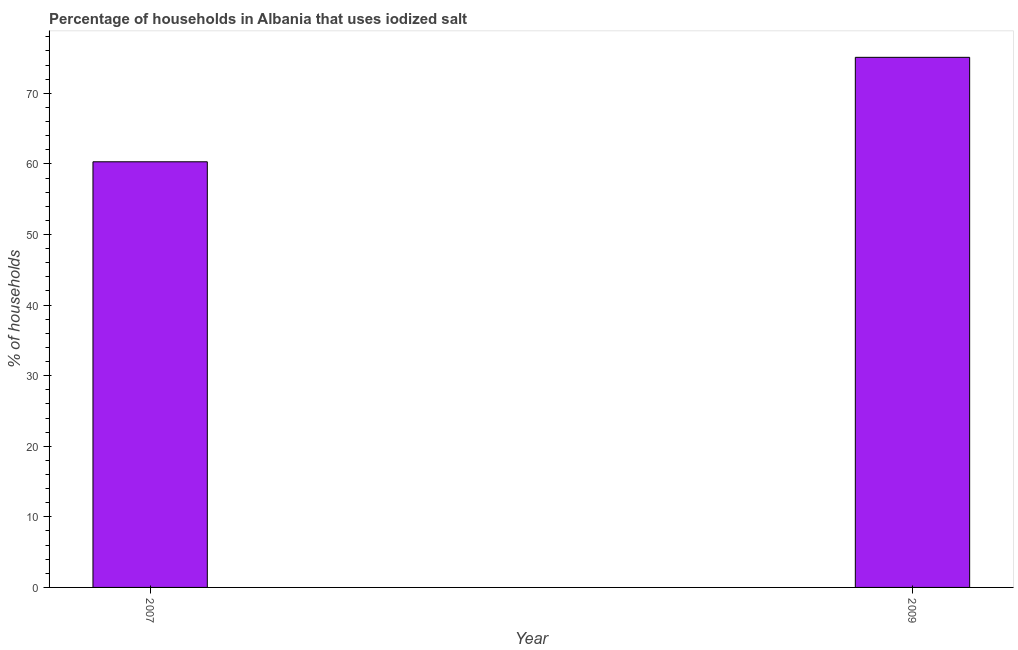Does the graph contain any zero values?
Your answer should be compact. No. Does the graph contain grids?
Your answer should be compact. No. What is the title of the graph?
Your response must be concise. Percentage of households in Albania that uses iodized salt. What is the label or title of the X-axis?
Your answer should be compact. Year. What is the label or title of the Y-axis?
Make the answer very short. % of households. What is the percentage of households where iodized salt is consumed in 2007?
Offer a terse response. 60.3. Across all years, what is the maximum percentage of households where iodized salt is consumed?
Your response must be concise. 75.1. Across all years, what is the minimum percentage of households where iodized salt is consumed?
Your response must be concise. 60.3. In which year was the percentage of households where iodized salt is consumed minimum?
Your answer should be very brief. 2007. What is the sum of the percentage of households where iodized salt is consumed?
Offer a terse response. 135.4. What is the difference between the percentage of households where iodized salt is consumed in 2007 and 2009?
Provide a succinct answer. -14.8. What is the average percentage of households where iodized salt is consumed per year?
Give a very brief answer. 67.7. What is the median percentage of households where iodized salt is consumed?
Provide a short and direct response. 67.7. What is the ratio of the percentage of households where iodized salt is consumed in 2007 to that in 2009?
Provide a succinct answer. 0.8. Is the percentage of households where iodized salt is consumed in 2007 less than that in 2009?
Give a very brief answer. Yes. What is the % of households in 2007?
Offer a very short reply. 60.3. What is the % of households of 2009?
Offer a very short reply. 75.1. What is the difference between the % of households in 2007 and 2009?
Provide a succinct answer. -14.8. What is the ratio of the % of households in 2007 to that in 2009?
Offer a terse response. 0.8. 